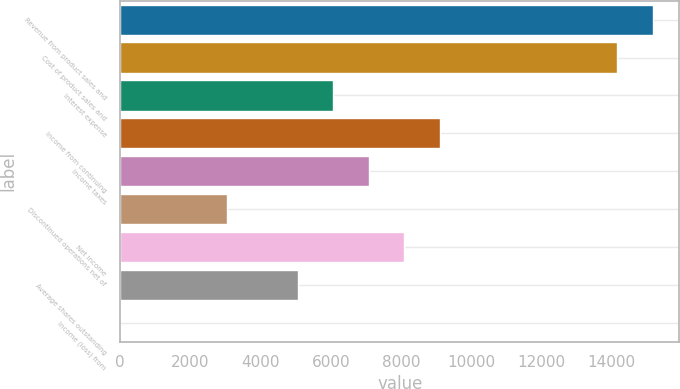Convert chart to OTSL. <chart><loc_0><loc_0><loc_500><loc_500><bar_chart><fcel>Revenue from product sales and<fcel>Cost of product sales and<fcel>Interest expense<fcel>Income from continuing<fcel>Income taxes<fcel>Discontinued operations net of<fcel>Net income<fcel>Average shares outstanding<fcel>Income (loss) from<nl><fcel>15167.6<fcel>14156.5<fcel>6067.46<fcel>9100.85<fcel>7078.59<fcel>3034.07<fcel>8089.72<fcel>5056.33<fcel>0.68<nl></chart> 